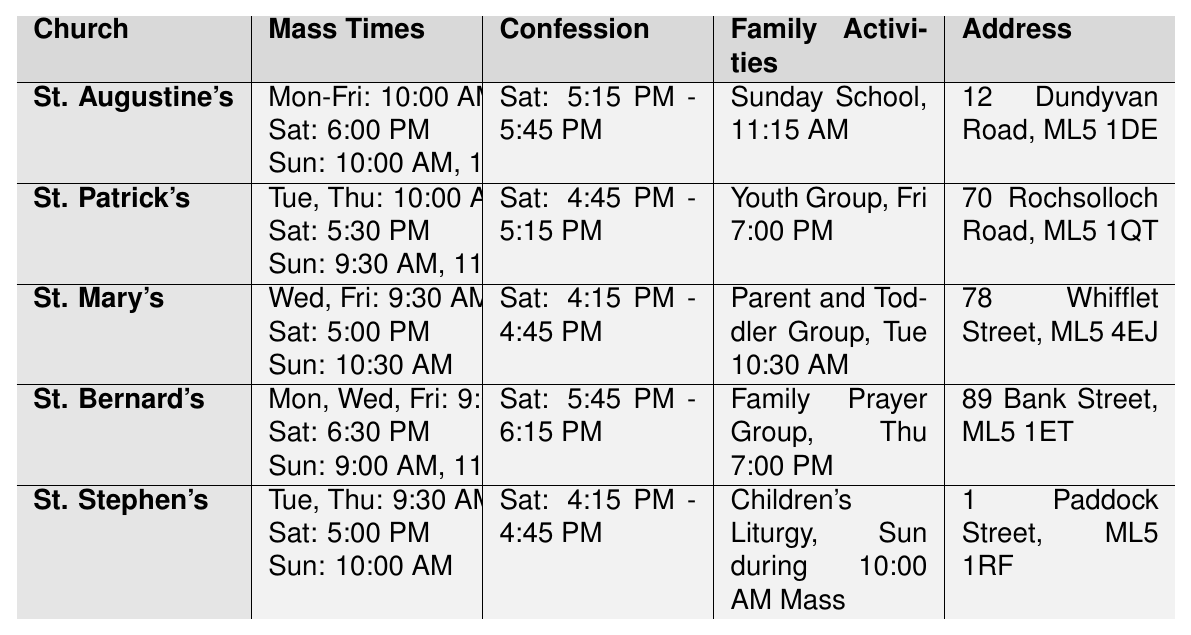What time is the weekday Mass at St. Augustine's Catholic Church? The table shows that the weekday Mass at St. Augustine's is held from Monday to Friday at 10:00 AM.
Answer: 10:00 AM Which church has a Saturday Vigil at 5:30 PM? By checking the Saturday Vigil times in the table, St. Patrick's Catholic Church offers a 5:30 PM Vigil.
Answer: St. Patrick's Catholic Church How many Sunday Mass times does St. Mary's Catholic Church have? St. Mary's offers one Sunday Mass at 10:30 AM, so the count of Sunday Mass times is one.
Answer: 1 Which church offers the Family Prayer Group activity? Looking at the Family Activities column, it is indicated that St. Bernard's Catholic Church holds a Family Prayer Group on Thursday at 7:00 PM.
Answer: St. Bernard's Catholic Church What is the difference in the number of Mass times between St. Patrick's and St. Stephen's on Sundays? St. Patrick's has two Sunday Mass times (9:30 AM and 11:30 AM), while St. Stephen's has one (10:00 AM). The difference is 2 - 1 = 1.
Answer: 1 False or true: St. Augustine's Catholic Church has a confession time on Sunday. The table does not list any confession times on Sunday for St. Augustine's, indicating the statement is false.
Answer: False What are the family activities available at St. Bernard's Catholic Church and St. Mary's Catholic Church? St. Bernard's offers a Family Prayer Group on Thursdays, while St. Mary's offers a Parent and Toddler Group on Tuesdays at 10:30 AM.
Answer: Family Prayer Group, Parent and Toddler Group Which church has the earliest weekday Mass among all listed? The earliest weekday Mass is held at St. Bernard's Catholic Church at 9:00 AM on Monday, Wednesday, and Friday, compared to other churches with later Mass times.
Answer: St. Bernard's Catholic Church What is the combined total of Sunday Mass times for both St. Augustine's and St. Mary's? St. Augustine's has two Sunday Mass times (10:00 AM and 12:00 PM), and St. Mary's has one (10:30 AM). The total is 2 + 1 = 3.
Answer: 3 Identify the church with the same confession times as St. Stephen's. By checking the Confession Times, it is noted that both St. Stephen's and St. Mary's have the same confession times (4:15 PM - 4:45 PM).
Answer: St. Mary's Catholic Church 